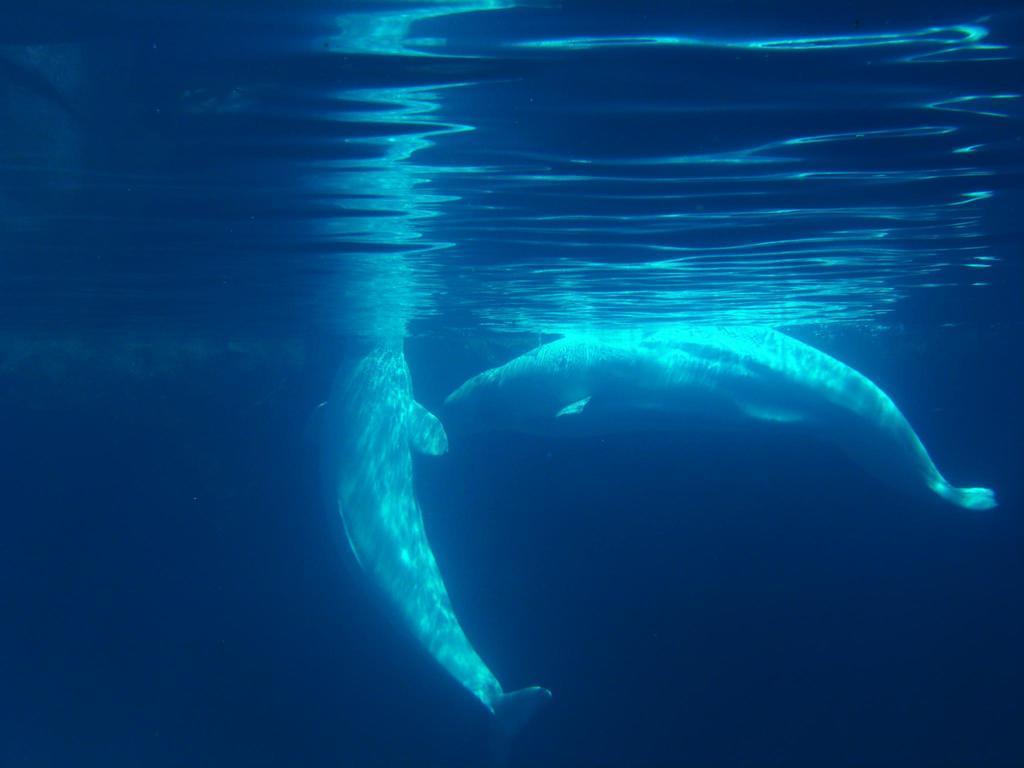Can you describe this image briefly? In this image there are two dolphins in the water. 